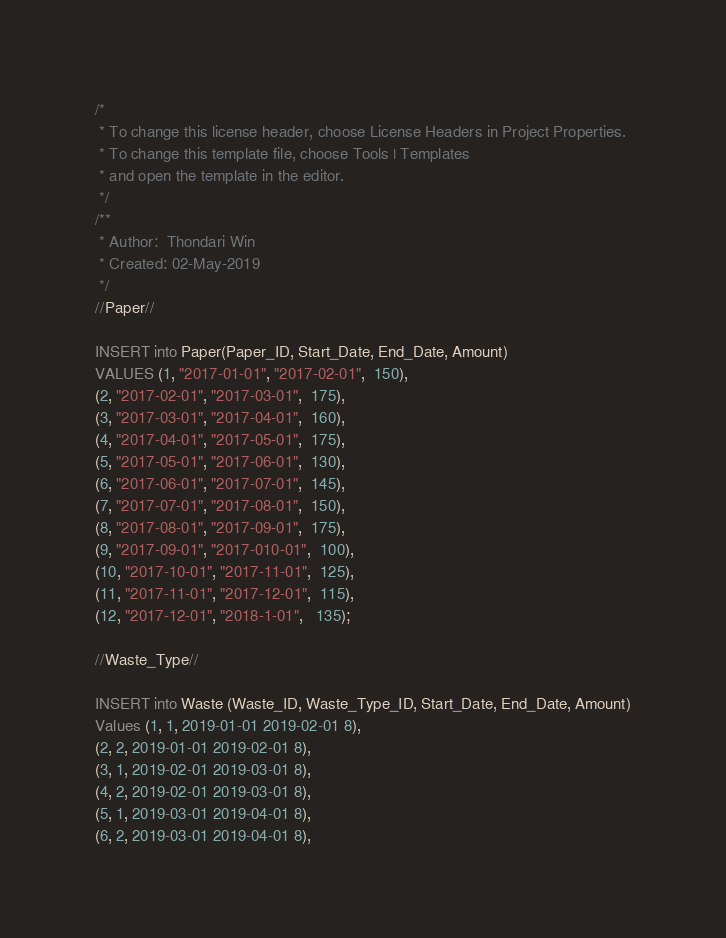<code> <loc_0><loc_0><loc_500><loc_500><_SQL_>/* 
 * To change this license header, choose License Headers in Project Properties.
 * To change this template file, choose Tools | Templates
 * and open the template in the editor.
 */
/**
 * Author:  Thondari Win
 * Created: 02-May-2019
 */
//Paper//

INSERT into Paper(Paper_ID, Start_Date, End_Date, Amount) 
VALUES (1, "2017-01-01", "2017-02-01",  150),
(2, "2017-02-01", "2017-03-01",  175),
(3, "2017-03-01", "2017-04-01",  160),
(4, "2017-04-01", "2017-05-01",  175),
(5, "2017-05-01", "2017-06-01",  130),
(6, "2017-06-01", "2017-07-01",  145),
(7, "2017-07-01", "2017-08-01",  150),
(8, "2017-08-01", "2017-09-01",  175),
(9, "2017-09-01", "2017-010-01",  100),
(10, "2017-10-01", "2017-11-01",  125),
(11, "2017-11-01", "2017-12-01",  115),
(12, "2017-12-01", "2018-1-01",   135);

//Waste_Type//

INSERT into Waste (Waste_ID, Waste_Type_ID, Start_Date, End_Date, Amount)
Values (1, 1, 2019-01-01 2019-02-01 8),
(2, 2, 2019-01-01 2019-02-01 8),
(3, 1, 2019-02-01 2019-03-01 8),
(4, 2, 2019-02-01 2019-03-01 8),
(5, 1, 2019-03-01 2019-04-01 8),
(6, 2, 2019-03-01 2019-04-01 8), </code> 